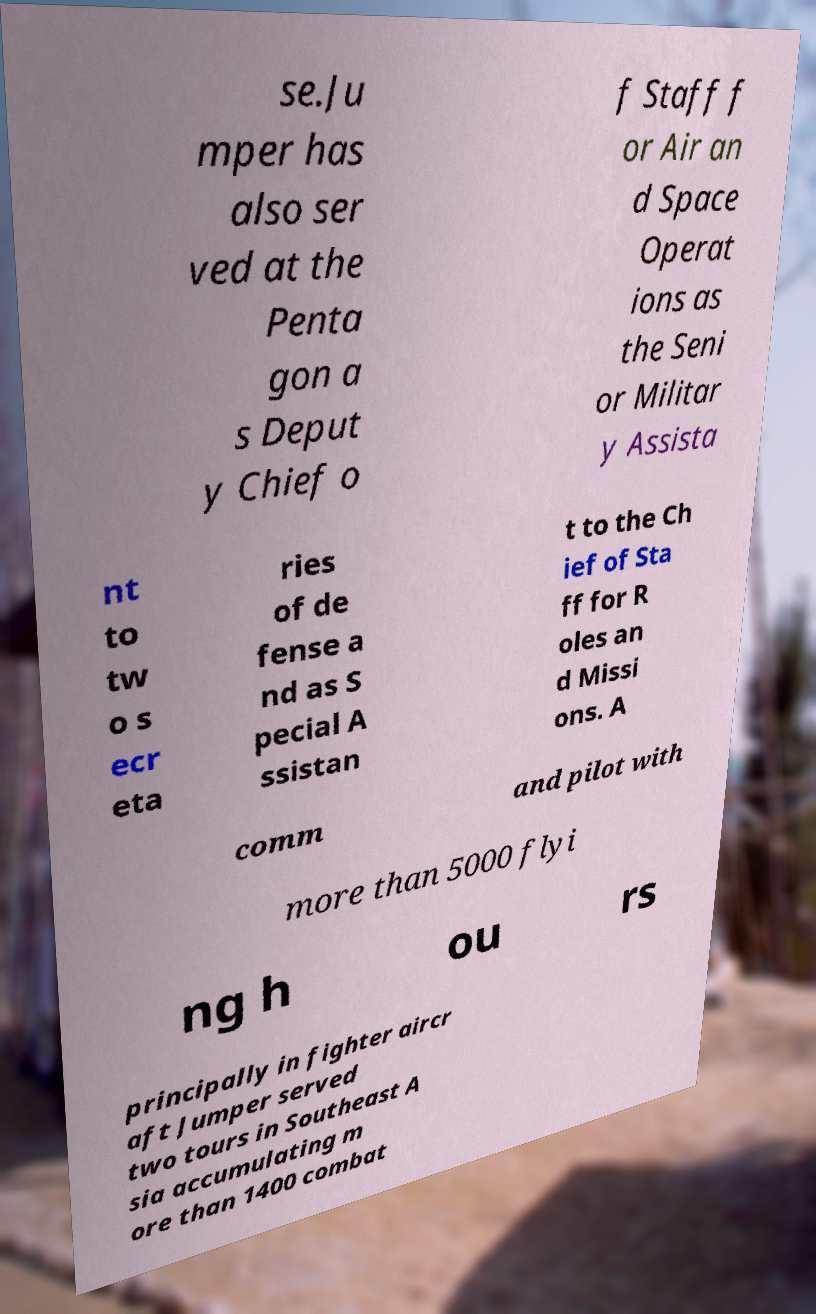I need the written content from this picture converted into text. Can you do that? se.Ju mper has also ser ved at the Penta gon a s Deput y Chief o f Staff f or Air an d Space Operat ions as the Seni or Militar y Assista nt to tw o s ecr eta ries of de fense a nd as S pecial A ssistan t to the Ch ief of Sta ff for R oles an d Missi ons. A comm and pilot with more than 5000 flyi ng h ou rs principally in fighter aircr aft Jumper served two tours in Southeast A sia accumulating m ore than 1400 combat 